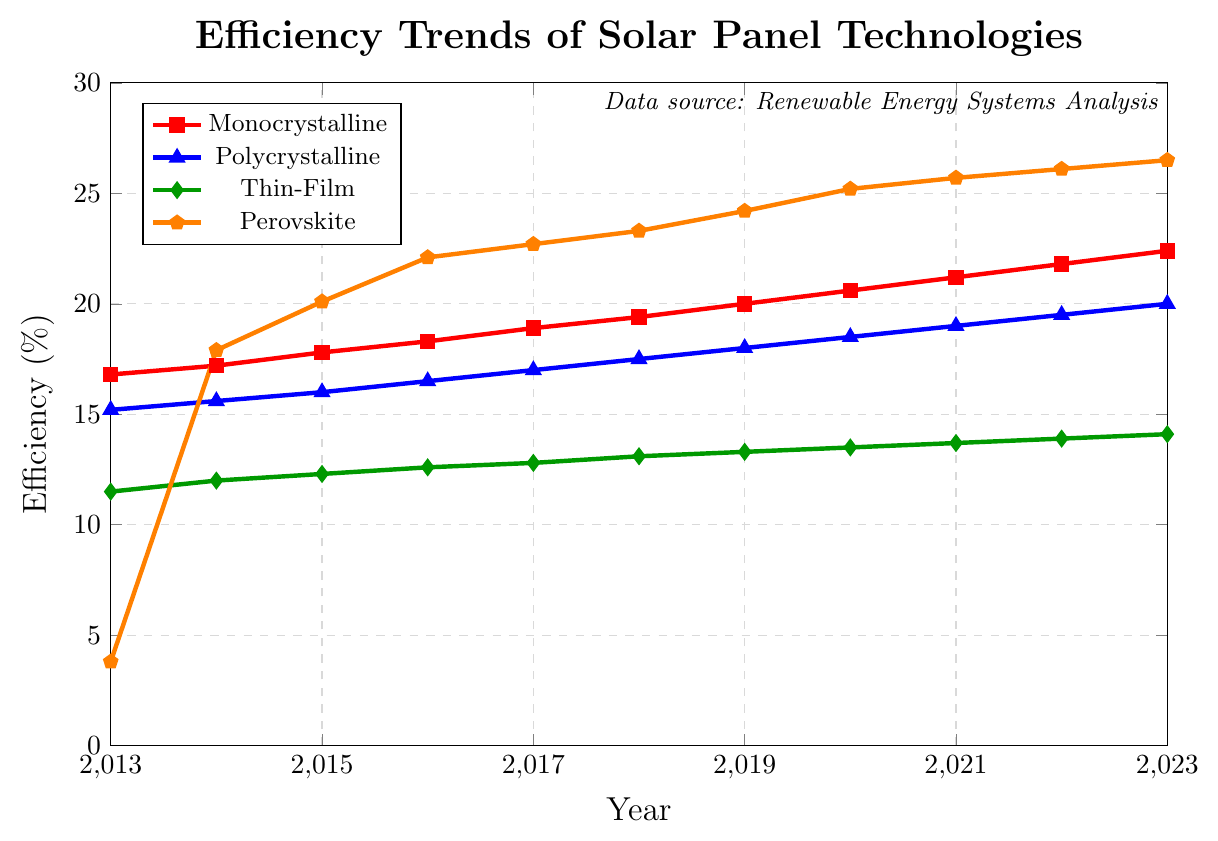What is the most efficient solar panel technology in 2023? The plot shows the efficiency trends for different solar panel technologies over the past decade. By observing the data points in 2023, Perovskite technology has the highest efficiency of 26.5%.
Answer: Perovskite Which solar panel technology had the greatest improvement in efficiency from 2013 to 2023? To determine the greatest improvement, subtract the 2013 efficiency from the 2023 efficiency for each technology. Monocrystalline improved by 22.4-16.8=5.6%, Polycrystalline by 20.0-15.2=4.8%, Thin-Film by 14.1-11.5=2.6%,  and Perovskite by 26.5-3.8=22.7%. Perovskite shows the greatest improvement.
Answer: Perovskite By how much did the efficiency of Monocrystalline solar panels increase from 2015 to 2020? Subtract the 2015 efficiency of Monocrystalline from the 2020 efficiency. 20.6% - 17.8% = 2.8%
Answer: 2.8% In which year did Polycrystalline solar panels first surpass 18% efficiency? By observing the efficiency data points for Polycrystalline technology, it first surpassed 18% in 2019.
Answer: 2019 What is the difference in efficiency between the highest and lowest solar panel technologies in 2021? Identify the highest and lowest efficiency values for 2021. Perovskite is at 25.7% and Thin-Film is at 13.7%. The difference is 25.7% - 13.7% = 12.0%.
Answer: 12.0% Which technology showed a continuous increase in efficiency every year? By examining the plot, Monocrystalline, Polycrystalline, and Perovskite all show a continuous increase in efficiency every year. Thin-Film also shows a continuous increase. All technologies exhibit this trend.
Answer: All technologies What is the average efficiency of Thin-Film technology from 2018 to 2023? Sum the efficiencies of Thin-Film for these years and divide by the number of years: (13.1 + 13.3 + 13.5 + 13.7 + 13.9 + 14.1) / 6 = 81.6 / 6 = 13.6
Answer: 13.6 Compare the efficiency values of Monocrystalline and Polycrystalline solar panels in 2017 and determine the difference. In 2017, Monocrystalline has an efficiency of 18.9% and Polycrystalline has 17.0%. The difference is 18.9% - 17.0% = 1.9%.
Answer: 1.9% 